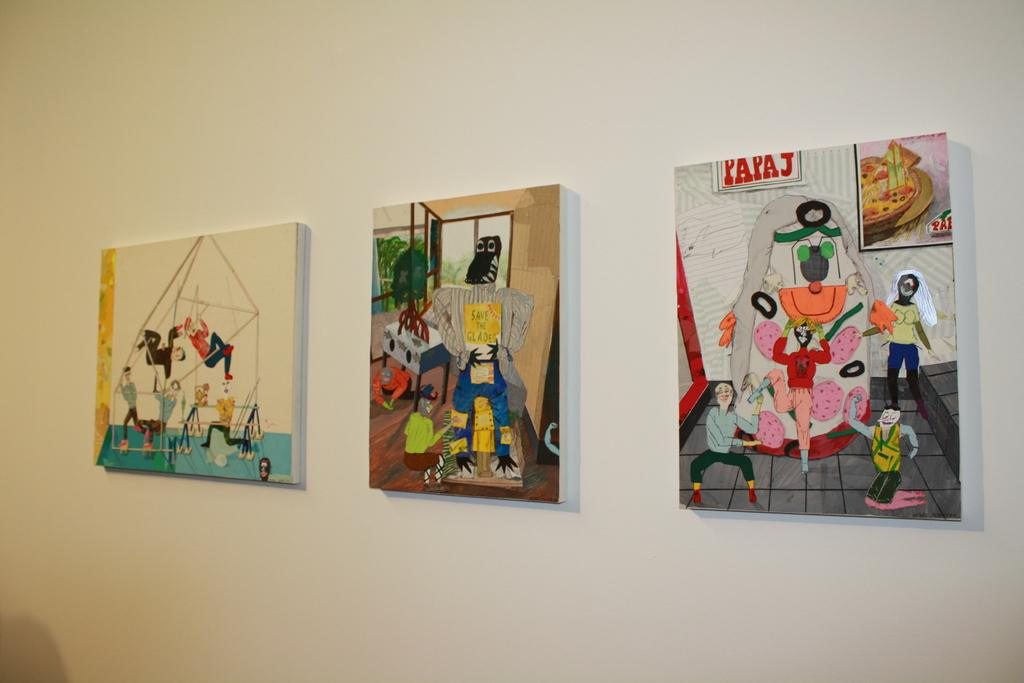What can be seen on the wall in the image? There are photo frames on the wall in the image. How many photo frames are visible on the wall? The number of photo frames cannot be determined from the provided fact. What might be displayed in the photo frames? The contents of the photo frames cannot be determined from the provided fact. How many horses are visible in the image? There are no horses present in the image; it only features photo frames on the wall. Are there any beds visible in the image? There is no mention of beds in the provided fact, so it cannot be determined if they are present in the image. 